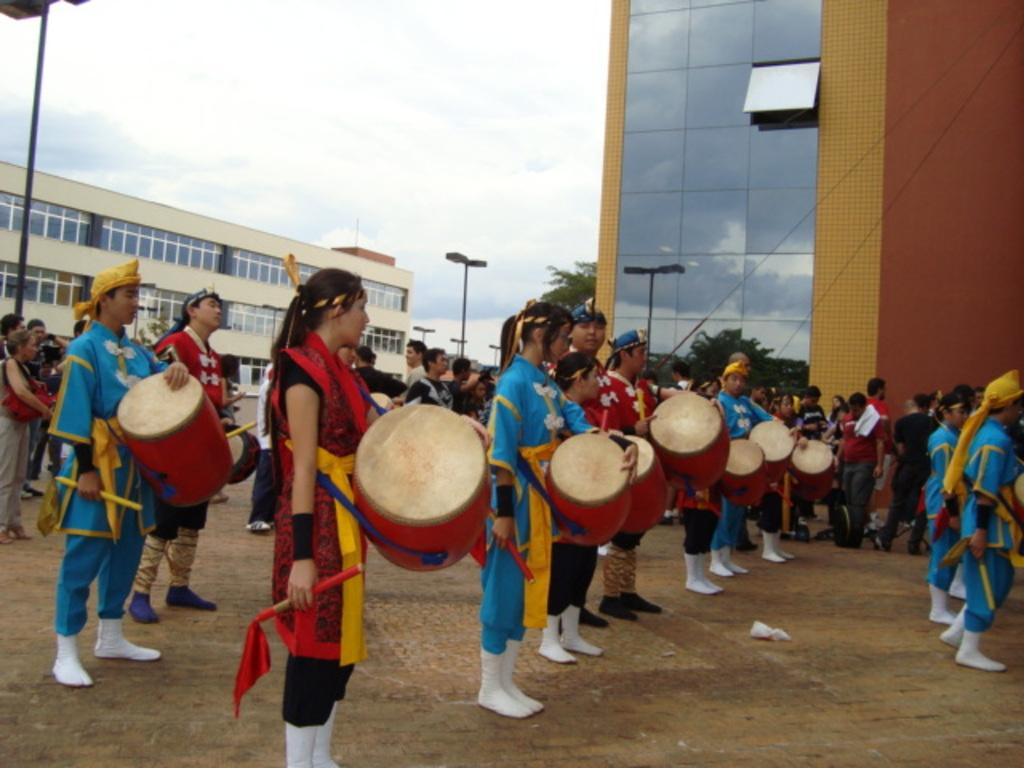What are the people in the image doing? The people in the image are playing musical instruments. What can be seen in the background of the image? There is a building and a pole in the background of the image. What is visible above the building and pole in the image? The sky is visible in the background of the image. What type of plate is being used by the musicians in the image? There is no plate visible in the image; the people are playing musical instruments. 